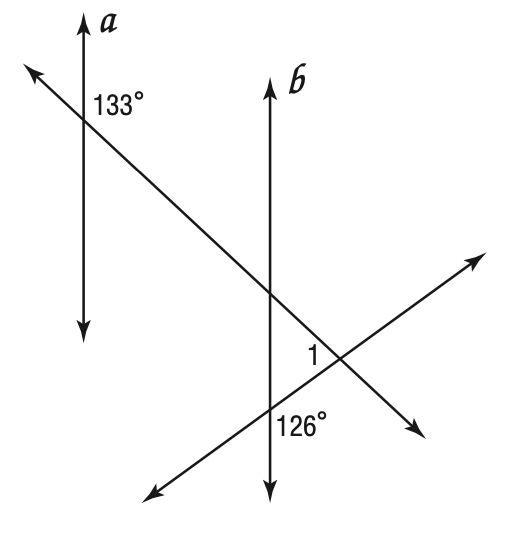Question: Given a \parallel b, find m \angle 1.
Choices:
A. 47
B. 54
C. 79
D. 101
Answer with the letter. Answer: C 